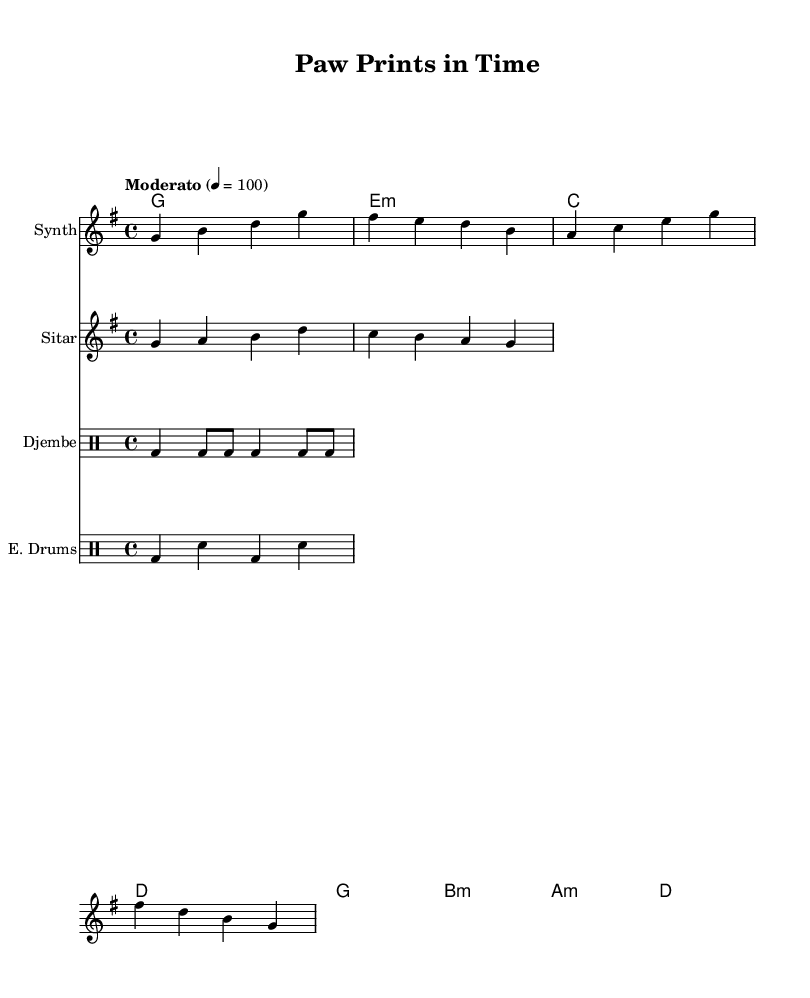What is the key signature of this music? The key signature is G major, which has one sharp (F#). This can be identified from the `\key g \major` directive in the code.
Answer: G major What is the time signature of this music? The time signature is 4/4, which means there are four beats in a measure. This is indicated in the code by the `\time 4/4` directive.
Answer: 4/4 What is the tempo marking for this piece? The tempo marking is Moderato, set at 100 beats per minute. This is stated in the code where it says `\tempo "Moderato" 4 = 100`.
Answer: Moderato How many measures are in the synth melody? The synth melody consists of 4 measures, as indicated by the grouped g4 b d g lines and each measure being separated by a vertical line in the notation.
Answer: 4 Which instrument plays the electronic drums? The instrument that plays the electronic drums is labeled as "E. Drums" in the fourth staff. This is clearly specified in the `\new DrumStaff \with { instrumentName = "E. Drums" }` section of the code.
Answer: E. Drums What type of fusion is represented in this piece of music? The piece represents a fusion of electronic and world music, specifically incorporating elements like synth and sitar alongside traditional percussion, aligning with the requested theme of reflecting on a dog handler's retirement journey.
Answer: Electronic world music fusion What is the chord progression listed in the music? The chord progression listed in the music follows the sequence G, E minor, C, D, G, B minor, A minor, D as outlined in the chordNames section of the code.
Answer: G, E minor, C, D, G, B minor, A minor, D 